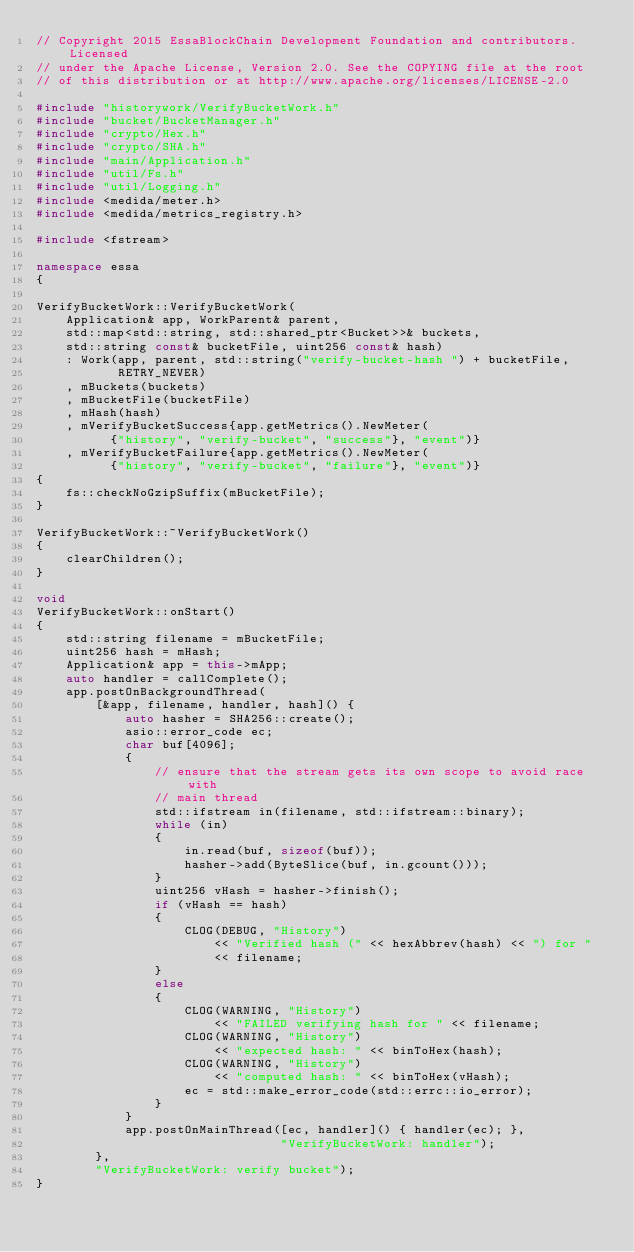Convert code to text. <code><loc_0><loc_0><loc_500><loc_500><_C++_>// Copyright 2015 EssaBlockChain Development Foundation and contributors. Licensed
// under the Apache License, Version 2.0. See the COPYING file at the root
// of this distribution or at http://www.apache.org/licenses/LICENSE-2.0

#include "historywork/VerifyBucketWork.h"
#include "bucket/BucketManager.h"
#include "crypto/Hex.h"
#include "crypto/SHA.h"
#include "main/Application.h"
#include "util/Fs.h"
#include "util/Logging.h"
#include <medida/meter.h>
#include <medida/metrics_registry.h>

#include <fstream>

namespace essa
{

VerifyBucketWork::VerifyBucketWork(
    Application& app, WorkParent& parent,
    std::map<std::string, std::shared_ptr<Bucket>>& buckets,
    std::string const& bucketFile, uint256 const& hash)
    : Work(app, parent, std::string("verify-bucket-hash ") + bucketFile,
           RETRY_NEVER)
    , mBuckets(buckets)
    , mBucketFile(bucketFile)
    , mHash(hash)
    , mVerifyBucketSuccess{app.getMetrics().NewMeter(
          {"history", "verify-bucket", "success"}, "event")}
    , mVerifyBucketFailure{app.getMetrics().NewMeter(
          {"history", "verify-bucket", "failure"}, "event")}
{
    fs::checkNoGzipSuffix(mBucketFile);
}

VerifyBucketWork::~VerifyBucketWork()
{
    clearChildren();
}

void
VerifyBucketWork::onStart()
{
    std::string filename = mBucketFile;
    uint256 hash = mHash;
    Application& app = this->mApp;
    auto handler = callComplete();
    app.postOnBackgroundThread(
        [&app, filename, handler, hash]() {
            auto hasher = SHA256::create();
            asio::error_code ec;
            char buf[4096];
            {
                // ensure that the stream gets its own scope to avoid race with
                // main thread
                std::ifstream in(filename, std::ifstream::binary);
                while (in)
                {
                    in.read(buf, sizeof(buf));
                    hasher->add(ByteSlice(buf, in.gcount()));
                }
                uint256 vHash = hasher->finish();
                if (vHash == hash)
                {
                    CLOG(DEBUG, "History")
                        << "Verified hash (" << hexAbbrev(hash) << ") for "
                        << filename;
                }
                else
                {
                    CLOG(WARNING, "History")
                        << "FAILED verifying hash for " << filename;
                    CLOG(WARNING, "History")
                        << "expected hash: " << binToHex(hash);
                    CLOG(WARNING, "History")
                        << "computed hash: " << binToHex(vHash);
                    ec = std::make_error_code(std::errc::io_error);
                }
            }
            app.postOnMainThread([ec, handler]() { handler(ec); },
                                 "VerifyBucketWork: handler");
        },
        "VerifyBucketWork: verify bucket");
}
</code> 